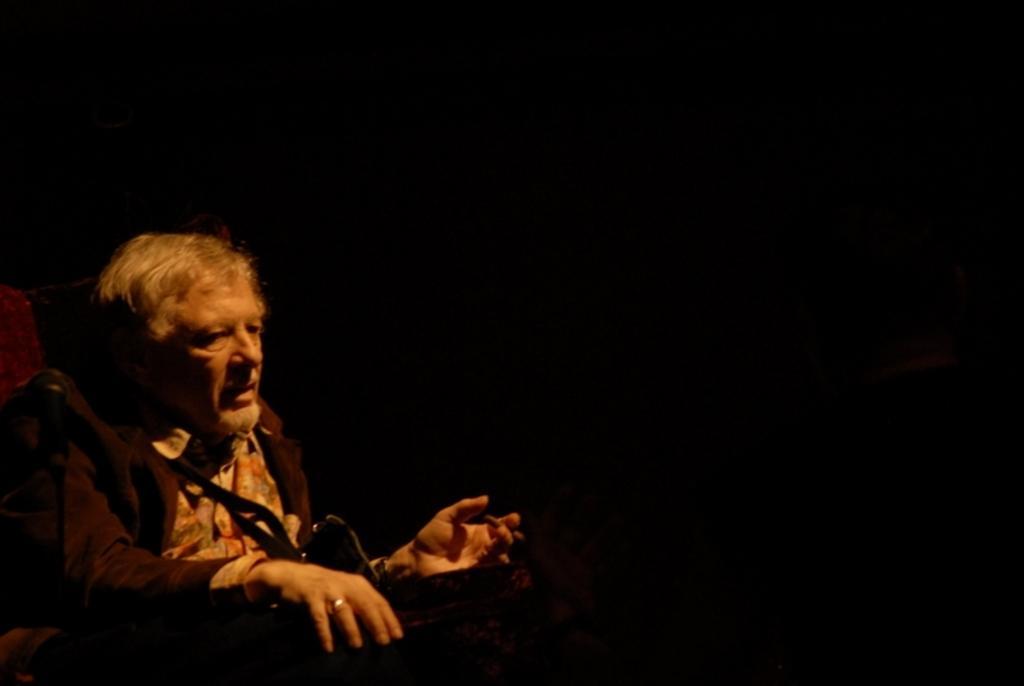Describe this image in one or two sentences. In this image I can see a man is sitting on the left side. I can also see black colour in the background. 